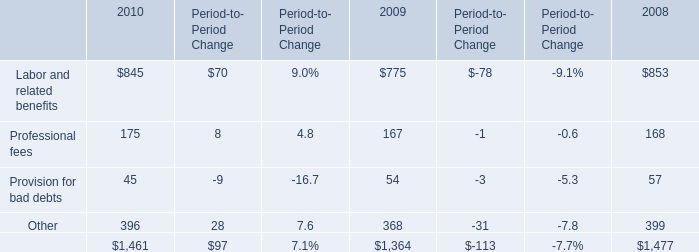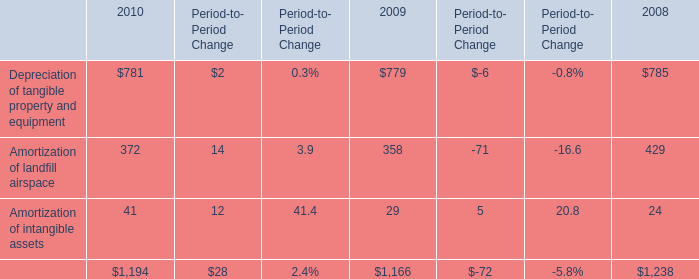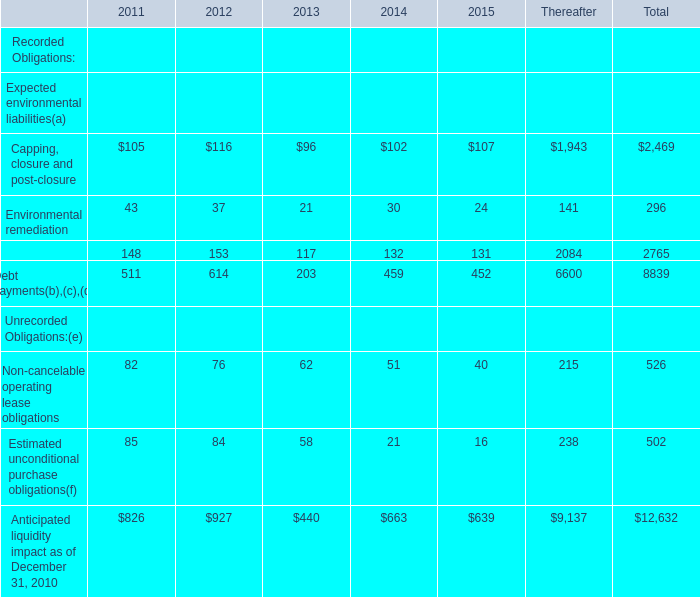What is the sum of elements in the range of 90 and 300 in 2013? 
Computations: (96 + 203)
Answer: 299.0. 